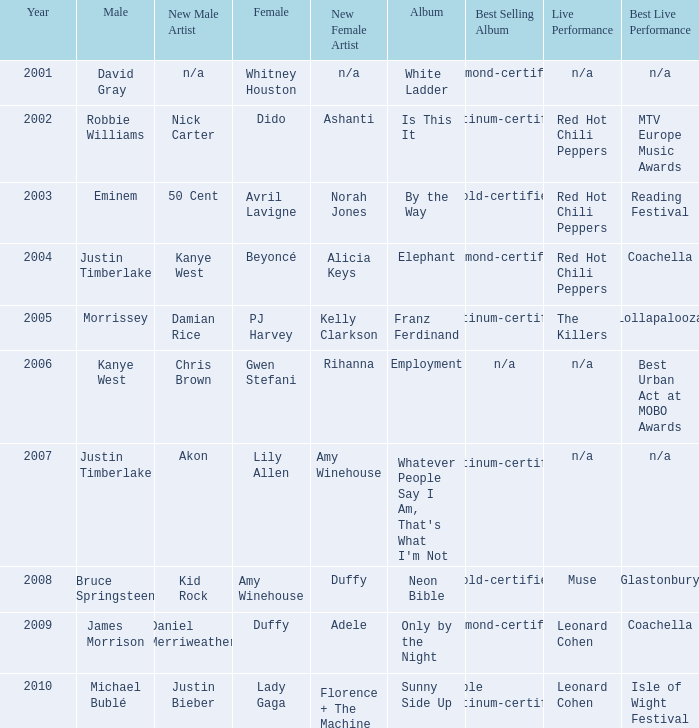Which female artist has an album named elephant? Beyoncé. 